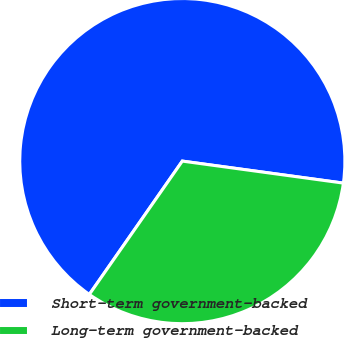Convert chart. <chart><loc_0><loc_0><loc_500><loc_500><pie_chart><fcel>Short-term government-backed<fcel>Long-term government-backed<nl><fcel>67.47%<fcel>32.53%<nl></chart> 